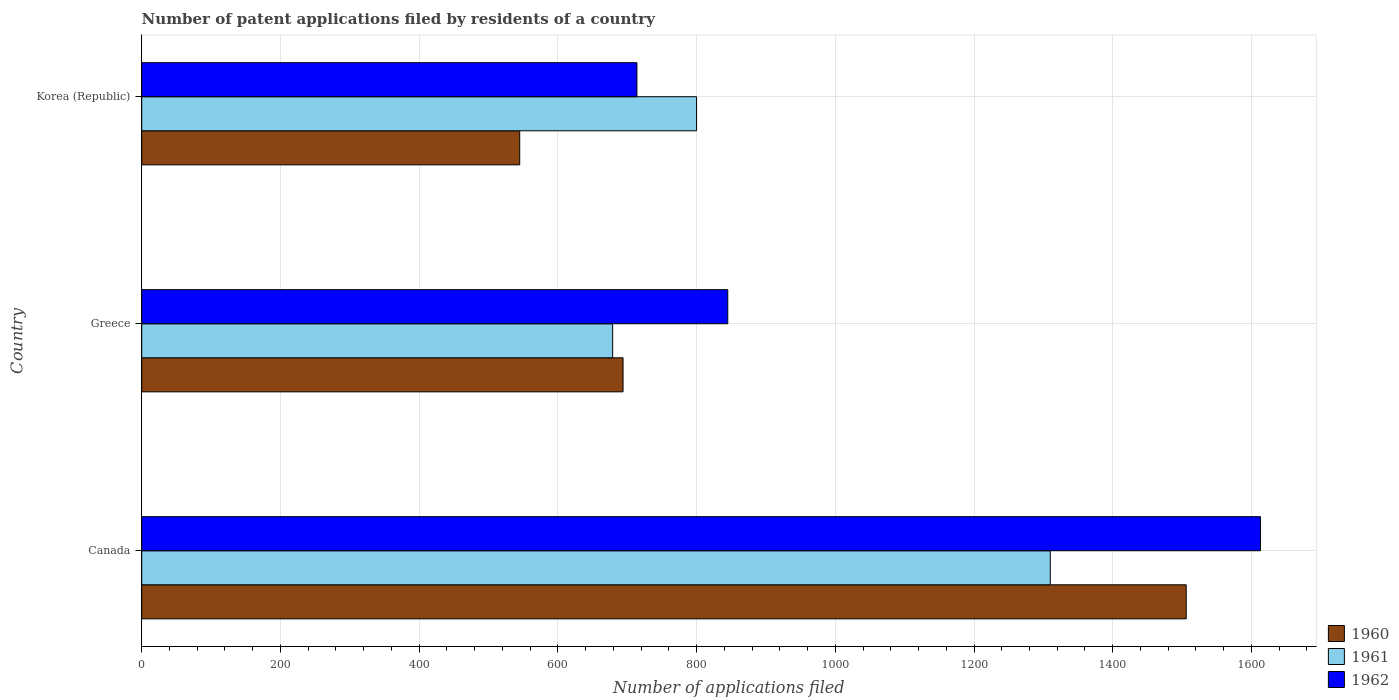How many different coloured bars are there?
Provide a short and direct response. 3. Are the number of bars per tick equal to the number of legend labels?
Your answer should be compact. Yes. Are the number of bars on each tick of the Y-axis equal?
Your answer should be compact. Yes. How many bars are there on the 2nd tick from the bottom?
Provide a short and direct response. 3. In how many cases, is the number of bars for a given country not equal to the number of legend labels?
Make the answer very short. 0. What is the number of applications filed in 1962 in Korea (Republic)?
Your response must be concise. 714. Across all countries, what is the maximum number of applications filed in 1960?
Provide a succinct answer. 1506. Across all countries, what is the minimum number of applications filed in 1960?
Provide a short and direct response. 545. What is the total number of applications filed in 1962 in the graph?
Your response must be concise. 3172. What is the difference between the number of applications filed in 1961 in Greece and that in Korea (Republic)?
Make the answer very short. -121. What is the difference between the number of applications filed in 1960 in Greece and the number of applications filed in 1962 in Korea (Republic)?
Your response must be concise. -20. What is the average number of applications filed in 1962 per country?
Give a very brief answer. 1057.33. What is the difference between the number of applications filed in 1961 and number of applications filed in 1960 in Canada?
Your answer should be compact. -196. What is the ratio of the number of applications filed in 1960 in Greece to that in Korea (Republic)?
Offer a very short reply. 1.27. Is the number of applications filed in 1962 in Greece less than that in Korea (Republic)?
Offer a very short reply. No. What is the difference between the highest and the second highest number of applications filed in 1962?
Ensure brevity in your answer.  768. What is the difference between the highest and the lowest number of applications filed in 1960?
Provide a succinct answer. 961. In how many countries, is the number of applications filed in 1960 greater than the average number of applications filed in 1960 taken over all countries?
Provide a succinct answer. 1. What does the 2nd bar from the top in Canada represents?
Offer a very short reply. 1961. What does the 3rd bar from the bottom in Canada represents?
Offer a terse response. 1962. Does the graph contain any zero values?
Offer a terse response. No. How are the legend labels stacked?
Make the answer very short. Vertical. What is the title of the graph?
Make the answer very short. Number of patent applications filed by residents of a country. What is the label or title of the X-axis?
Offer a terse response. Number of applications filed. What is the label or title of the Y-axis?
Provide a succinct answer. Country. What is the Number of applications filed of 1960 in Canada?
Give a very brief answer. 1506. What is the Number of applications filed in 1961 in Canada?
Offer a very short reply. 1310. What is the Number of applications filed of 1962 in Canada?
Provide a short and direct response. 1613. What is the Number of applications filed in 1960 in Greece?
Keep it short and to the point. 694. What is the Number of applications filed of 1961 in Greece?
Offer a very short reply. 679. What is the Number of applications filed of 1962 in Greece?
Your answer should be compact. 845. What is the Number of applications filed of 1960 in Korea (Republic)?
Your answer should be very brief. 545. What is the Number of applications filed in 1961 in Korea (Republic)?
Provide a succinct answer. 800. What is the Number of applications filed of 1962 in Korea (Republic)?
Offer a very short reply. 714. Across all countries, what is the maximum Number of applications filed in 1960?
Your response must be concise. 1506. Across all countries, what is the maximum Number of applications filed of 1961?
Your response must be concise. 1310. Across all countries, what is the maximum Number of applications filed of 1962?
Ensure brevity in your answer.  1613. Across all countries, what is the minimum Number of applications filed of 1960?
Your answer should be compact. 545. Across all countries, what is the minimum Number of applications filed of 1961?
Your answer should be very brief. 679. Across all countries, what is the minimum Number of applications filed in 1962?
Give a very brief answer. 714. What is the total Number of applications filed in 1960 in the graph?
Offer a terse response. 2745. What is the total Number of applications filed in 1961 in the graph?
Offer a terse response. 2789. What is the total Number of applications filed of 1962 in the graph?
Your answer should be very brief. 3172. What is the difference between the Number of applications filed in 1960 in Canada and that in Greece?
Offer a terse response. 812. What is the difference between the Number of applications filed in 1961 in Canada and that in Greece?
Your response must be concise. 631. What is the difference between the Number of applications filed of 1962 in Canada and that in Greece?
Your answer should be very brief. 768. What is the difference between the Number of applications filed in 1960 in Canada and that in Korea (Republic)?
Your answer should be very brief. 961. What is the difference between the Number of applications filed of 1961 in Canada and that in Korea (Republic)?
Your answer should be compact. 510. What is the difference between the Number of applications filed of 1962 in Canada and that in Korea (Republic)?
Provide a short and direct response. 899. What is the difference between the Number of applications filed of 1960 in Greece and that in Korea (Republic)?
Give a very brief answer. 149. What is the difference between the Number of applications filed in 1961 in Greece and that in Korea (Republic)?
Your answer should be compact. -121. What is the difference between the Number of applications filed in 1962 in Greece and that in Korea (Republic)?
Offer a terse response. 131. What is the difference between the Number of applications filed in 1960 in Canada and the Number of applications filed in 1961 in Greece?
Give a very brief answer. 827. What is the difference between the Number of applications filed of 1960 in Canada and the Number of applications filed of 1962 in Greece?
Offer a terse response. 661. What is the difference between the Number of applications filed of 1961 in Canada and the Number of applications filed of 1962 in Greece?
Keep it short and to the point. 465. What is the difference between the Number of applications filed of 1960 in Canada and the Number of applications filed of 1961 in Korea (Republic)?
Offer a very short reply. 706. What is the difference between the Number of applications filed of 1960 in Canada and the Number of applications filed of 1962 in Korea (Republic)?
Provide a short and direct response. 792. What is the difference between the Number of applications filed of 1961 in Canada and the Number of applications filed of 1962 in Korea (Republic)?
Your answer should be compact. 596. What is the difference between the Number of applications filed of 1960 in Greece and the Number of applications filed of 1961 in Korea (Republic)?
Keep it short and to the point. -106. What is the difference between the Number of applications filed of 1960 in Greece and the Number of applications filed of 1962 in Korea (Republic)?
Offer a terse response. -20. What is the difference between the Number of applications filed in 1961 in Greece and the Number of applications filed in 1962 in Korea (Republic)?
Your answer should be very brief. -35. What is the average Number of applications filed in 1960 per country?
Keep it short and to the point. 915. What is the average Number of applications filed of 1961 per country?
Offer a very short reply. 929.67. What is the average Number of applications filed of 1962 per country?
Offer a terse response. 1057.33. What is the difference between the Number of applications filed in 1960 and Number of applications filed in 1961 in Canada?
Provide a succinct answer. 196. What is the difference between the Number of applications filed of 1960 and Number of applications filed of 1962 in Canada?
Offer a terse response. -107. What is the difference between the Number of applications filed in 1961 and Number of applications filed in 1962 in Canada?
Provide a short and direct response. -303. What is the difference between the Number of applications filed in 1960 and Number of applications filed in 1961 in Greece?
Offer a terse response. 15. What is the difference between the Number of applications filed of 1960 and Number of applications filed of 1962 in Greece?
Your response must be concise. -151. What is the difference between the Number of applications filed in 1961 and Number of applications filed in 1962 in Greece?
Offer a very short reply. -166. What is the difference between the Number of applications filed in 1960 and Number of applications filed in 1961 in Korea (Republic)?
Keep it short and to the point. -255. What is the difference between the Number of applications filed of 1960 and Number of applications filed of 1962 in Korea (Republic)?
Offer a terse response. -169. What is the difference between the Number of applications filed in 1961 and Number of applications filed in 1962 in Korea (Republic)?
Provide a succinct answer. 86. What is the ratio of the Number of applications filed of 1960 in Canada to that in Greece?
Give a very brief answer. 2.17. What is the ratio of the Number of applications filed of 1961 in Canada to that in Greece?
Keep it short and to the point. 1.93. What is the ratio of the Number of applications filed in 1962 in Canada to that in Greece?
Provide a succinct answer. 1.91. What is the ratio of the Number of applications filed of 1960 in Canada to that in Korea (Republic)?
Provide a succinct answer. 2.76. What is the ratio of the Number of applications filed of 1961 in Canada to that in Korea (Republic)?
Make the answer very short. 1.64. What is the ratio of the Number of applications filed of 1962 in Canada to that in Korea (Republic)?
Offer a very short reply. 2.26. What is the ratio of the Number of applications filed of 1960 in Greece to that in Korea (Republic)?
Keep it short and to the point. 1.27. What is the ratio of the Number of applications filed of 1961 in Greece to that in Korea (Republic)?
Your answer should be compact. 0.85. What is the ratio of the Number of applications filed of 1962 in Greece to that in Korea (Republic)?
Your response must be concise. 1.18. What is the difference between the highest and the second highest Number of applications filed of 1960?
Make the answer very short. 812. What is the difference between the highest and the second highest Number of applications filed of 1961?
Provide a succinct answer. 510. What is the difference between the highest and the second highest Number of applications filed in 1962?
Keep it short and to the point. 768. What is the difference between the highest and the lowest Number of applications filed in 1960?
Your answer should be very brief. 961. What is the difference between the highest and the lowest Number of applications filed in 1961?
Ensure brevity in your answer.  631. What is the difference between the highest and the lowest Number of applications filed in 1962?
Provide a succinct answer. 899. 